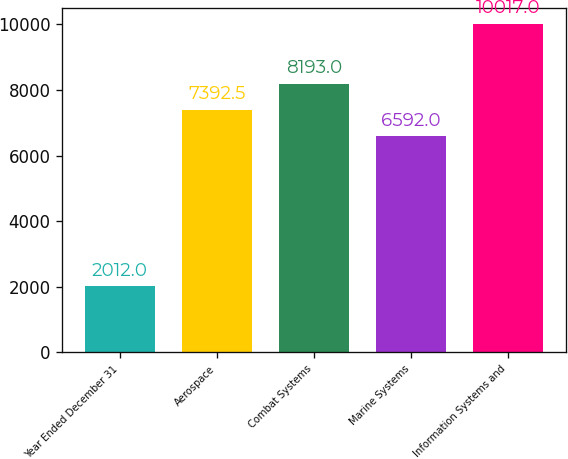Convert chart to OTSL. <chart><loc_0><loc_0><loc_500><loc_500><bar_chart><fcel>Year Ended December 31<fcel>Aerospace<fcel>Combat Systems<fcel>Marine Systems<fcel>Information Systems and<nl><fcel>2012<fcel>7392.5<fcel>8193<fcel>6592<fcel>10017<nl></chart> 